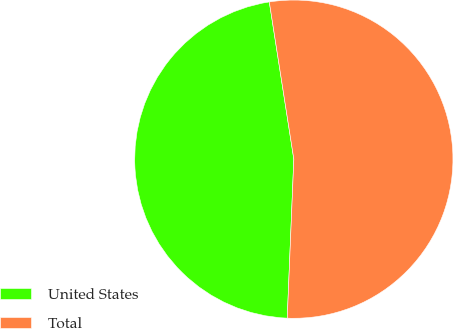Convert chart to OTSL. <chart><loc_0><loc_0><loc_500><loc_500><pie_chart><fcel>United States<fcel>Total<nl><fcel>46.88%<fcel>53.12%<nl></chart> 